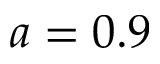<formula> <loc_0><loc_0><loc_500><loc_500>a = 0 . 9</formula> 